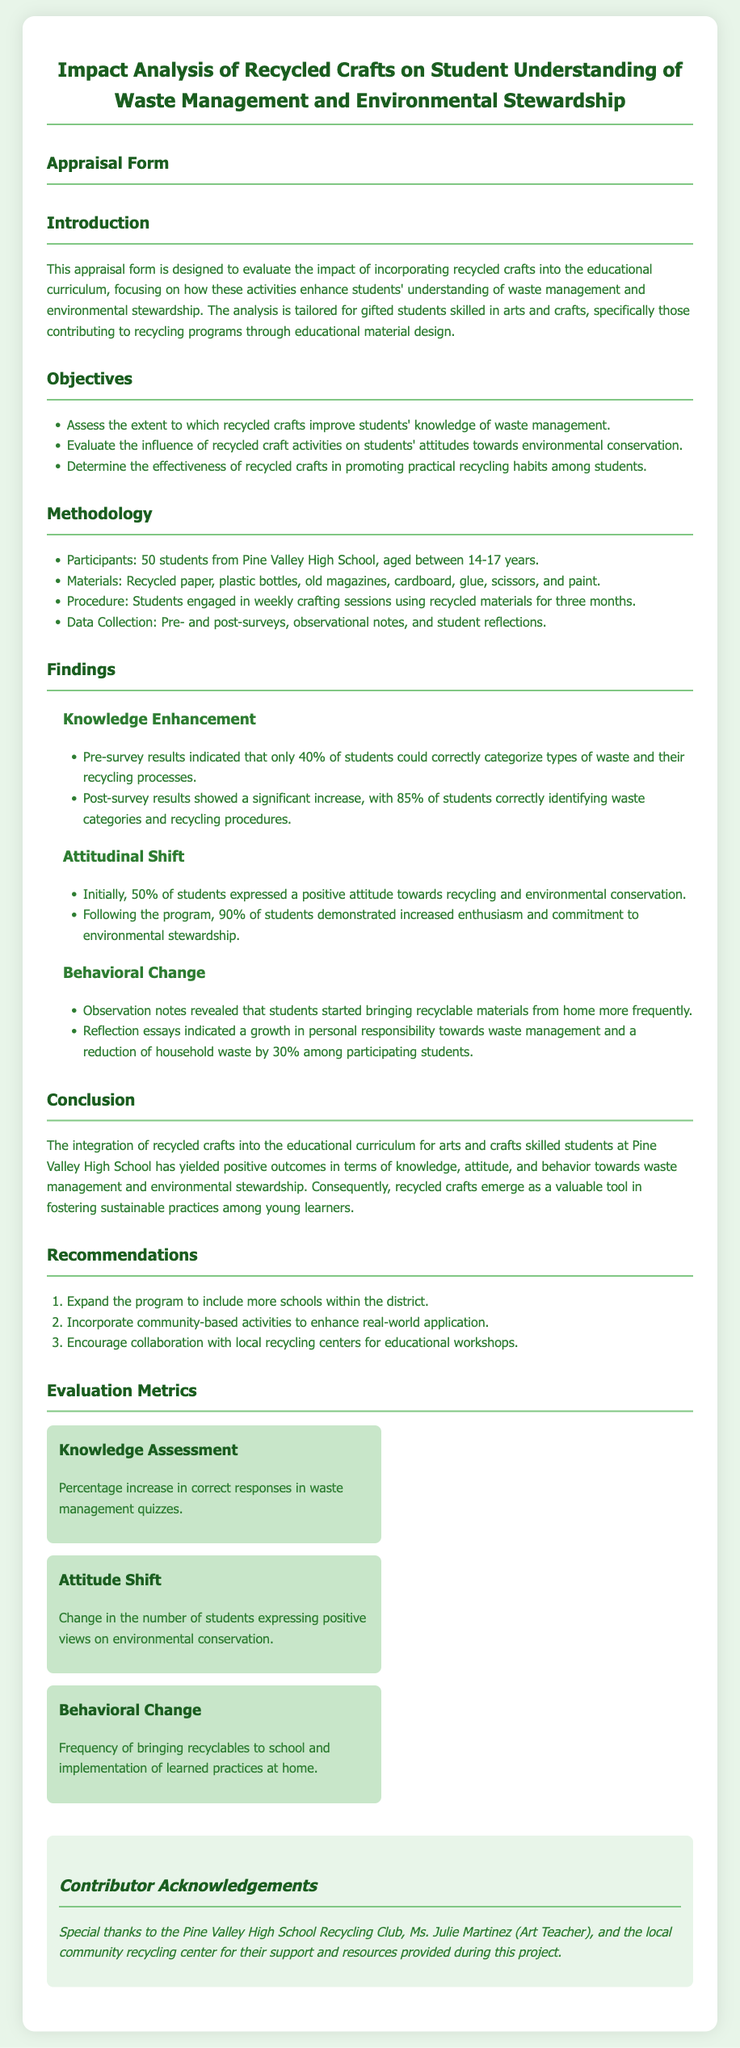what is the title of the document? The title is stated at the top of the document in a prominent font.
Answer: Impact Analysis of Recycled Crafts on Student Understanding of Waste Management and Environmental Stewardship how many students participated in the study? The number of participants is clearly mentioned in the methodology section of the document.
Answer: 50 students what percentage of students could correctly categorize types of waste before the program? This percentage is found within the findings related to knowledge enhancement.
Answer: 40% what was the increase in the number of students expressing positive views on environmental conservation after the program? This information can be gleaned from the attitudinal shift findings.
Answer: 40% name one of the materials used in the crafting sessions. The materials list in the methodology section outlines available supplies for the sessions.
Answer: Recycled paper what is one recommendation provided in the document? Recommendations are listed at the end and provide further steps for the program.
Answer: Expand the program to include more schools within the district what percentage of students demonstrated increased enthusiasm towards environmental stewardship after the program? This statistic is included in the attitudinal shift findings section.
Answer: 90% which group contributed to the project as per the acknowledgments? The contributor acknowledgments section lists involved groups and individuals.
Answer: Pine Valley High School Recycling Club what method was used for data collection in the study? The methodology section outlines the different methods utilized for gathering data.
Answer: Pre- and post-surveys 